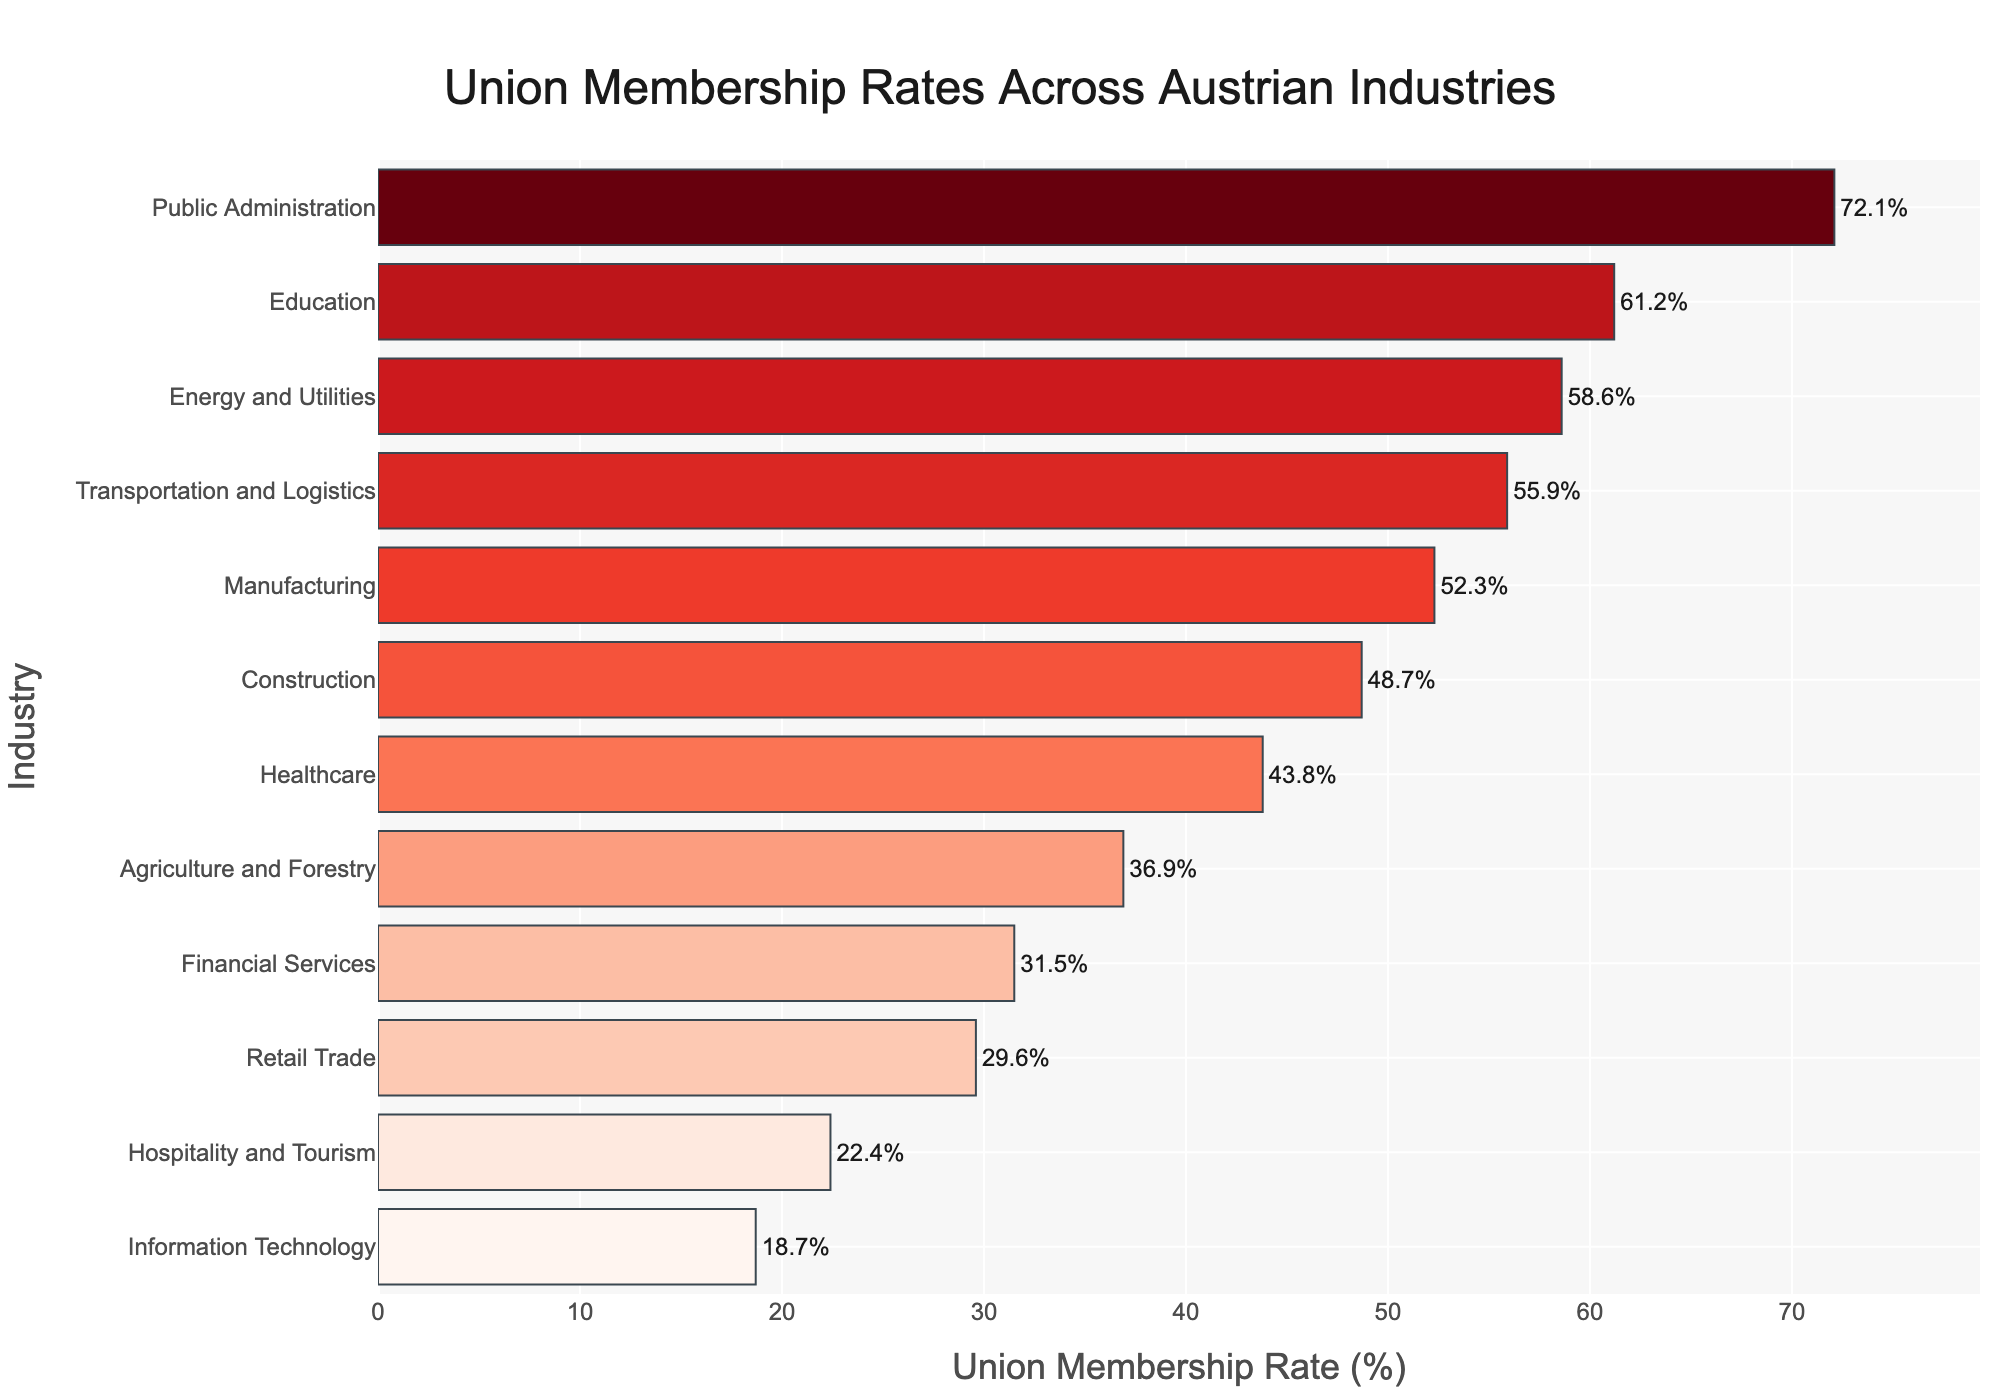What's the industry with the highest union membership rate? The industry with the highest union membership rate has the longest bar in the bar chart. Public Administration has the longest bar.
Answer: Public Administration Which industry has a higher union membership rate: Healthcare or Transportation and Logistics? Compare the lengths of the bars for Healthcare and Transportation and Logistics. The bar for Transportation and Logistics is longer.
Answer: Transportation and Logistics What's the difference in union membership rate between Manufacturing and Retail Trade? Find the union membership rates for Manufacturing (52.3%) and Retail Trade (29.6%), then subtract the Retail Trade rate from the Manufacturing rate: 52.3% - 29.6%.
Answer: 22.7% Which industry has the lowest union membership rate? The industry with the lowest union membership rate has the shortest bar in the chart. Information Technology has the shortest bar.
Answer: Information Technology What is the average union membership rate of the Hospitality and Tourism, Retail Trade, and Information Technology industries? Add the union membership rates of Hospitality and Tourism (22.4%), Retail Trade (29.6%), and Information Technology (18.7%), then divide by 3 to find the average: (22.4% + 29.6% + 18.7%)/3.
Answer: 23.57% Compare the union membership rate of Education with the average union membership rate across all industries? First, calculate the average union membership rate across all industries. Sum all rates and divide by the number of industries: (52.3 + 48.7 + 55.9 + 61.2 + 43.8 + 29.6 + 22.4 + 72.1 + 58.6 + 31.5 + 36.9 + 18.7)/12 = 43.975%. Now, compare Education's rate (61.2%) with this average.
Answer: Higher What's the difference between the union membership rates of the industry with the highest rate and the industry with the lowest rate? The highest rate is Public Administration (72.1%) and the lowest is Information Technology (18.7%). Subtract the lowest rate from the highest rate: 72.1% - 18.7%.
Answer: 53.4% How many industries have a union membership rate greater than 50%? Count the number of industries with union membership rates above 50% by checking the chart. Manufacturing, Transportation and Logistics, Education, Public Administration, and Energy and Utilities all have rates above 50%.
Answer: 5 